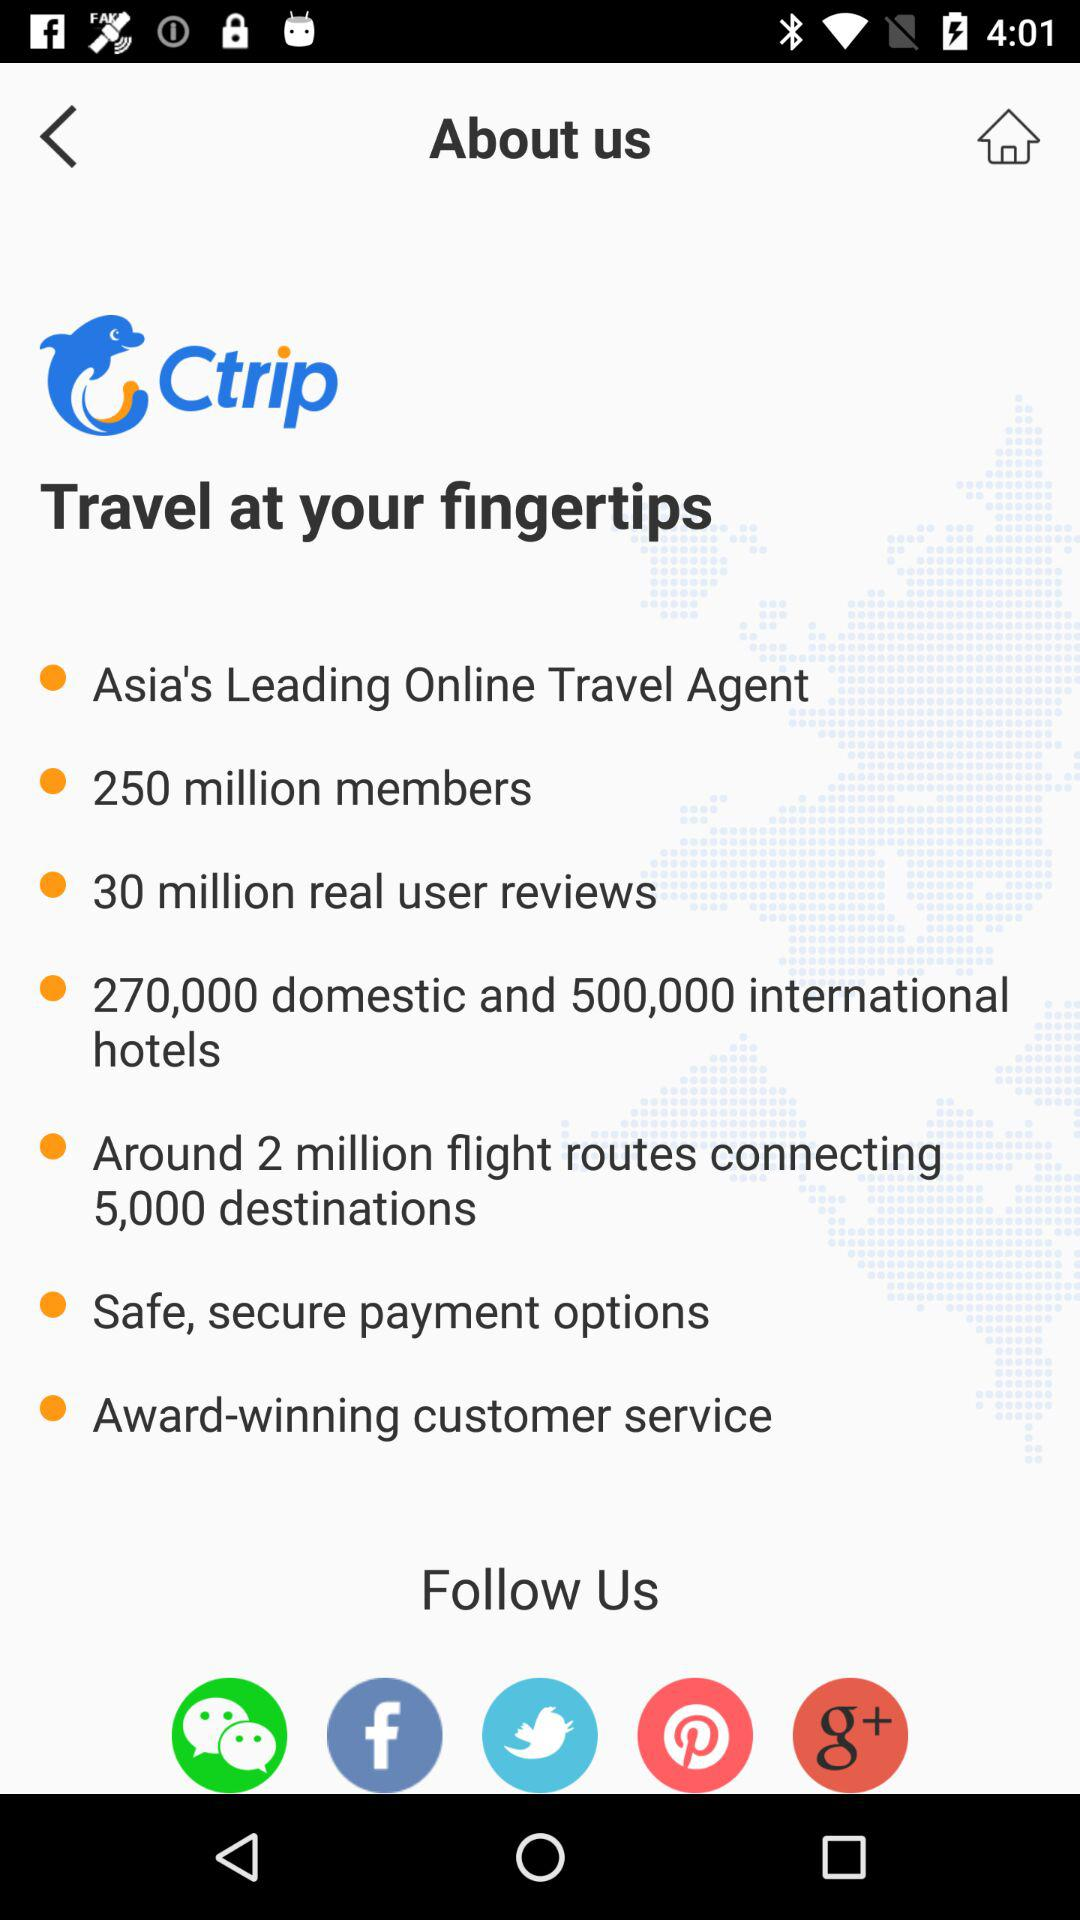How many domestic and international hotels are there? There are 270,000 domestic and 500,000 international hotels. 